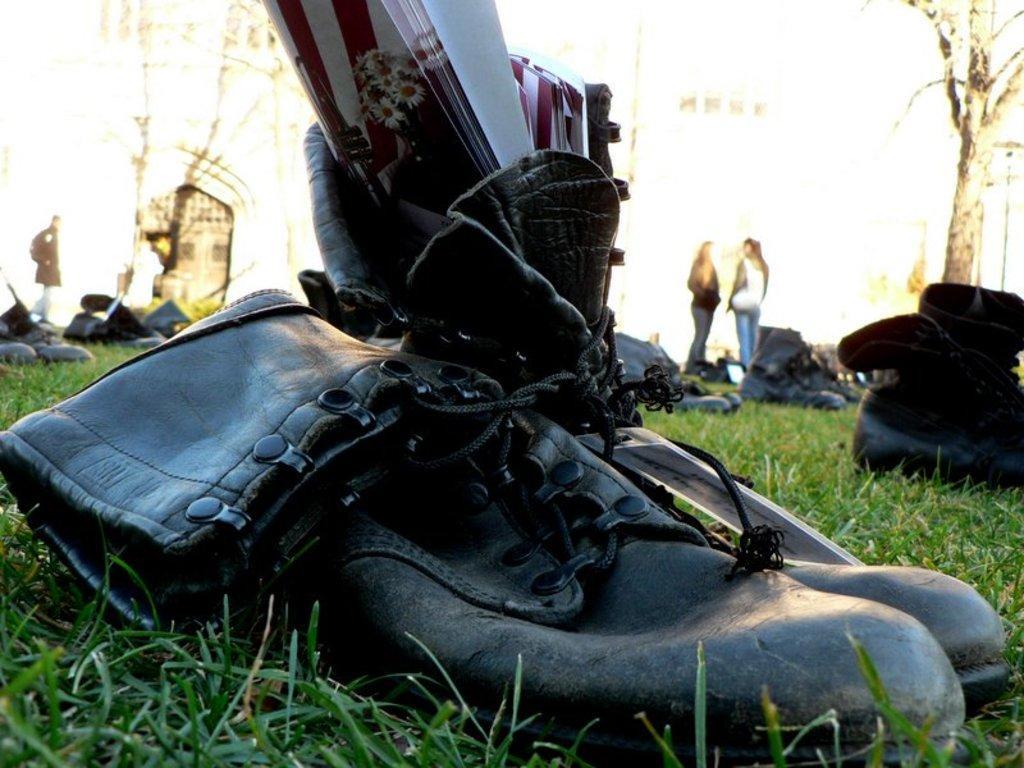How would you summarize this image in a sentence or two? Here we can see a pair of shoes on the ground and there is a book in one shoe. In the background we can see pairs of shoes on the ground and on the left there is a person walking on the ground and on the right there are two women standing on the ground,trees and few other objects. 